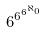Convert formula to latex. <formula><loc_0><loc_0><loc_500><loc_500>6 ^ { 6 ^ { 6 ^ { \aleph _ { 0 } } } }</formula> 